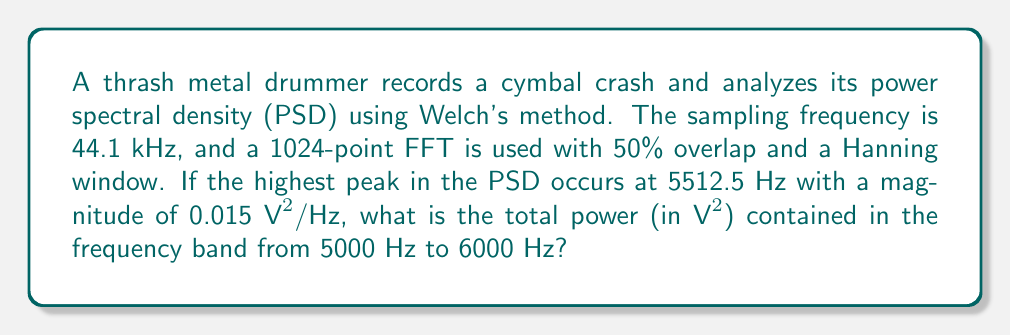Show me your answer to this math problem. Let's approach this step-by-step:

1) First, we need to understand the frequency resolution of our PSD estimate. With a sampling frequency of 44.1 kHz and a 1024-point FFT, the frequency resolution is:

   $$\Delta f = \frac{f_s}{N_{FFT}} = \frac{44100}{1024} \approx 43.07 \text{ Hz}$$

2) The frequency band of interest (5000 Hz to 6000 Hz) spans approximately:

   $$N_{bins} = \frac{6000 - 5000}{\Delta f} \approx 23.22 \text{ bins}$$

   We'll round this to 23 bins for our calculation.

3) To estimate the total power, we need to sum the PSD values over these bins and multiply by the frequency resolution. However, we only know the peak value (0.015 $\text{V}^2/\text{Hz}$).

4) As a rough approximation, let's assume the PSD follows a triangular shape around the peak, decreasing to zero at the edges of our band. The average PSD value would then be half the peak value:

   $$\text{PSD}_{\text{avg}} = \frac{0.015}{2} = 0.0075 \text{ V}^2/\text{Hz}$$

5) Now we can estimate the total power:

   $$P_{\text{total}} = \text{PSD}_{\text{avg}} \cdot N_{bins} \cdot \Delta f$$
   $$P_{\text{total}} = 0.0075 \cdot 23 \cdot 43.07 \approx 7.43 \text{ V}^2$$
Answer: $7.43 \text{ V}^2$ 